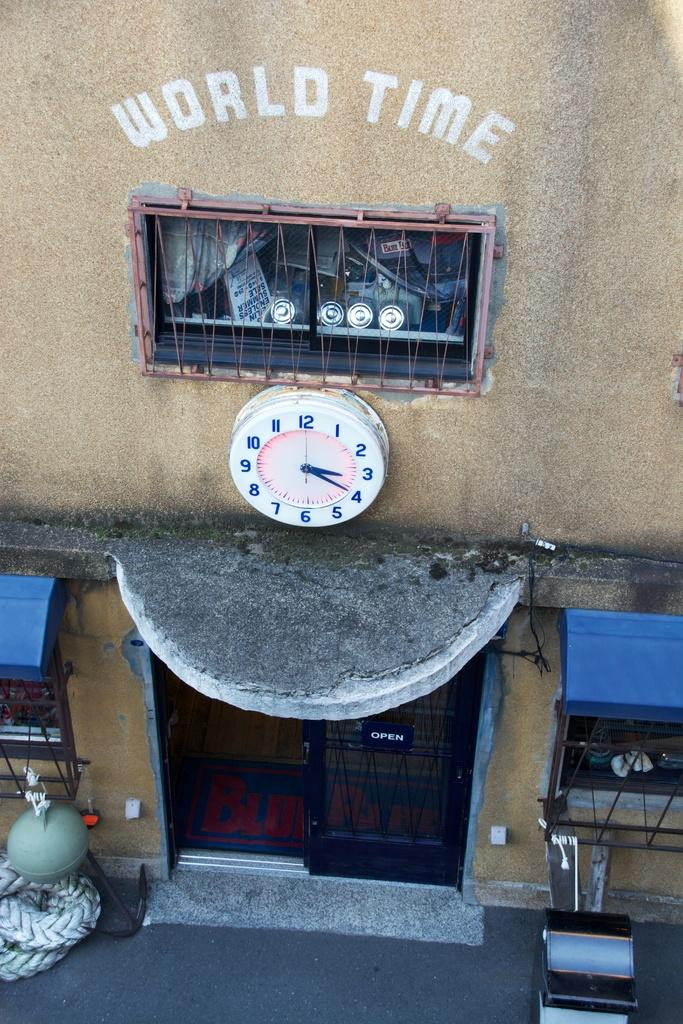<image>
Offer a succinct explanation of the picture presented. The time is 3:20 and World Time is open. 